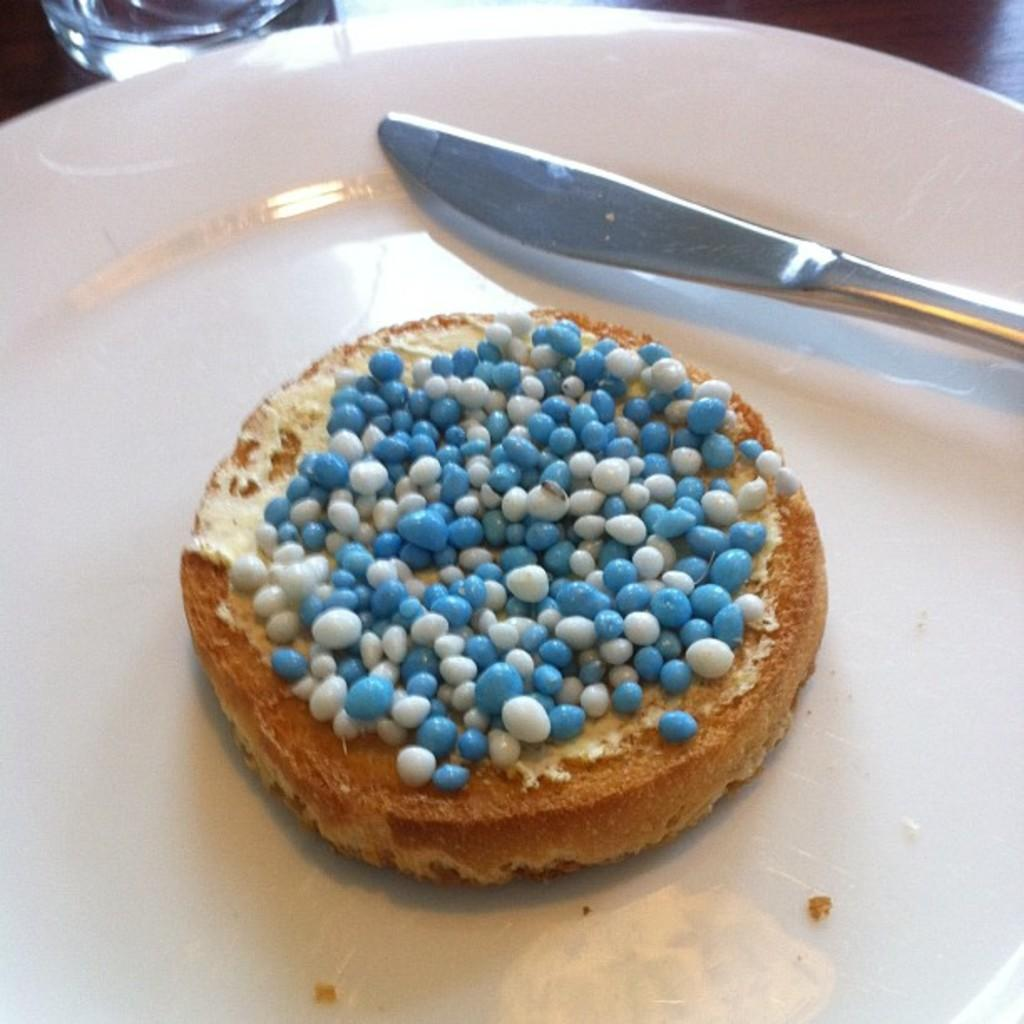What is the main subject in the center of the image? There is a cake in the center of the image. What is placed next to the cake? There is a knife in the plate with the cake. Where are the cake and knife located? The cake and knife are placed on a table. What can be seen in the top left corner of the image? There is a glass in the top left corner of the image. What type of sheet is draped over the cake in the image? There is no sheet present in the image; it features a cake with a knife on a table and a glass in the top left corner. 